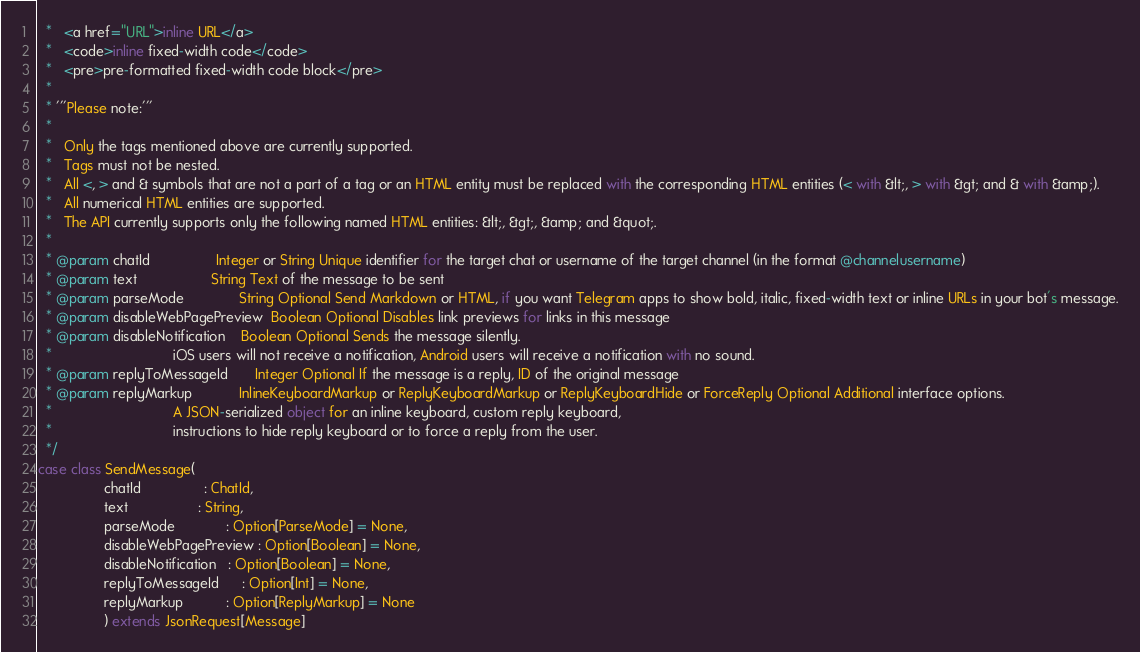<code> <loc_0><loc_0><loc_500><loc_500><_Scala_>  *   <a href="URL">inline URL</a>
  *   <code>inline fixed-width code</code>
  *   <pre>pre-formatted fixed-width code block</pre>
  *
  * '''Please note:'''
  *
  *   Only the tags mentioned above are currently supported.
  *   Tags must not be nested.
  *   All <, > and & symbols that are not a part of a tag or an HTML entity must be replaced with the corresponding HTML entities (< with &lt;, > with &gt; and & with &amp;).
  *   All numerical HTML entities are supported.
  *   The API currently supports only the following named HTML entities: &lt;, &gt;, &amp; and &quot;.
  *
  * @param chatId                 Integer or String Unique identifier for the target chat or username of the target channel (in the format @channelusername)
  * @param text                   String Text of the message to be sent
  * @param parseMode              String Optional Send Markdown or HTML, if you want Telegram apps to show bold, italic, fixed-width text or inline URLs in your bot's message.
  * @param disableWebPagePreview  Boolean Optional Disables link previews for links in this message
  * @param disableNotification    Boolean Optional Sends the message silently.
  *                               iOS users will not receive a notification, Android users will receive a notification with no sound.
  * @param replyToMessageId       Integer Optional If the message is a reply, ID of the original message
  * @param replyMarkup            InlineKeyboardMarkup or ReplyKeyboardMarkup or ReplyKeyboardHide or ForceReply Optional Additional interface options.
  *                               A JSON-serialized object for an inline keyboard, custom reply keyboard,
  *                               instructions to hide reply keyboard or to force a reply from the user.
  */
case class SendMessage(
                 chatId                : ChatId,
                 text                  : String,
                 parseMode             : Option[ParseMode] = None,
                 disableWebPagePreview : Option[Boolean] = None,
                 disableNotification   : Option[Boolean] = None,
                 replyToMessageId      : Option[Int] = None,
                 replyMarkup           : Option[ReplyMarkup] = None
                 ) extends JsonRequest[Message]
</code> 